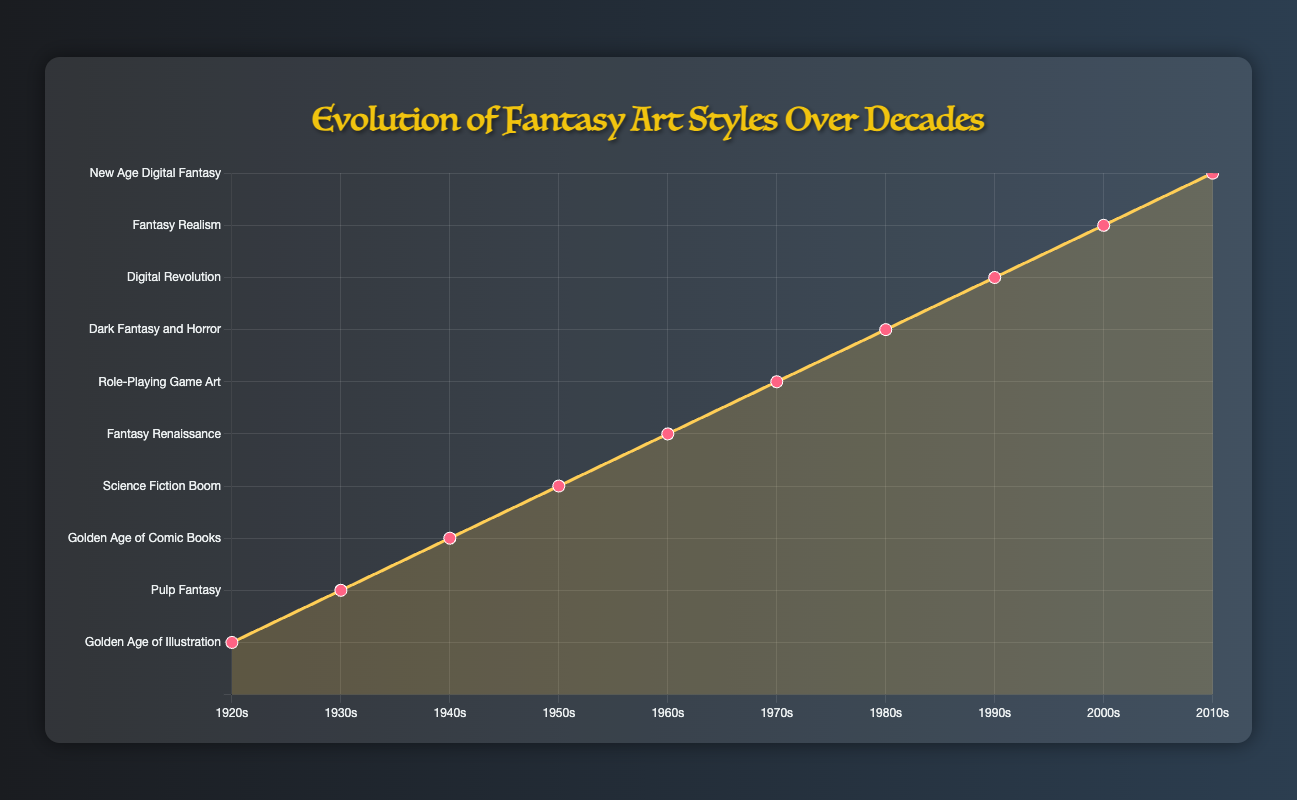What is the main artistic movement represented in the 1940s? To find this, look at the point corresponding to the 1940s on the x-axis and check the y-axis label at that point. According to the tooltip information, the artistic movement in the 1940s is "Golden Age of Comic Books."
Answer: Golden Age of Comic Books Which decade features artists like John Howe and Alan Lee, and what are the key influences of that period? First, identify the decade by looking for the names "John Howe" and "Alan Lee" among the notable artists listed in the tooltips. They are associated with the 2000s. According to the tooltip, the key influences of the 2000s are "Movies like 'Lord of the Rings'" and "MMORPGs."
Answer: 2000s, Movies like 'Lord of the Rings', MMORPGs Compare the futuristic themes of the 1950s with the technological influences of the 1990s. How do these themes differ in their representation of fantasy art? First locate the 1950s and 1990s on the x-axis. The 1950s emphasized "Futuristic themes" and "Exaggerated forms," influenced by the Atomic Age and Space Exploration. In contrast, the 1990s focused on "Fantasy meets technology" via "Mixed media techniques," influenced by Digital Art Tools and Anime. The 1950s had a more visionary, exaggerated style, while the 1990s integrated technology more directly through mixed media.
Answer: Futuristic themes of exaggerated forms vs. fantasy meets technology in mixed media How did the 1960s differ from the 1970s in terms of key influences on fantasy art? Check the tooltips for the 1960s and 1970s. The 1960s were influenced by "Counterculture" and "Psychadelic Art," resulting in bright colors and abstract patterns. The 1970s were influenced by "Dungeons & Dragons" and "Heavy Metal Magazine," leading to detailed textures and epic fantasy scenes.
Answer: 1960s: Counterculture, Psychedelic Art; 1970s: Dungeons & Dragons, Heavy Metal Magazine Identify which decade is represented by the highest point on the chart and describe its main artistic movement and key influences. The highest point likely corresponds to the most recent point on the chart, which is the 2010s. The main artistic movement for the 2010s is "New Age Digital Fantasy," influenced by Social Media and Indie Games.
Answer: 2010s, New Age Digital Fantasy, Social Media, Indie Games What are the main style characteristics of the fantasy art movement in the 1930s, and how do they compare to those in the 1940s? Access the tooltips for the 1930s and 1940s. The 1930s featured "Vibrant color palettes" and "Dynamic action scenes" under "Pulp Fantasy." The 1940s, influenced by World War II and Film Noir, had "Dark, moody atmospheres" and "Heavy use of chiaroscuro." The 1930s emphasized vibrancy and action, while the 1940s focused on darkness and mood.
Answer: 1930s: Vibrant color palettes, dynamic action scenes; 1940s: Dark, moody atmospheres, heavy use of chiaroscuro 